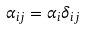<formula> <loc_0><loc_0><loc_500><loc_500>\alpha _ { i j } = \alpha _ { i } \delta _ { i j }</formula> 